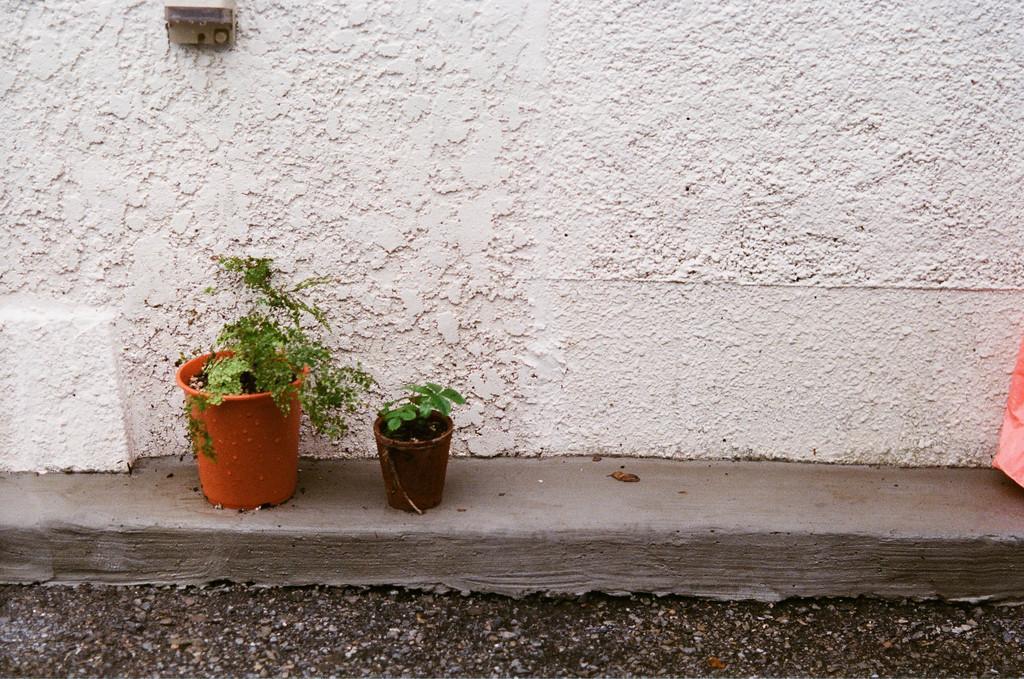Please provide a concise description of this image. In the picture we can see a wall which is made up of cement on it, we can see two house plants and in the background we can see a wall which is white in color. 